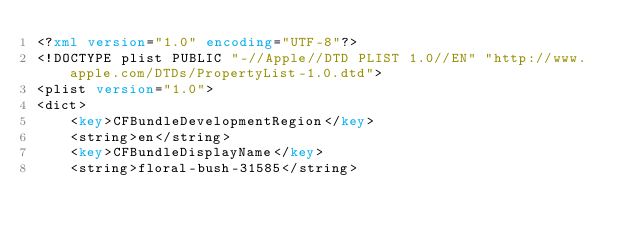<code> <loc_0><loc_0><loc_500><loc_500><_XML_><?xml version="1.0" encoding="UTF-8"?>
<!DOCTYPE plist PUBLIC "-//Apple//DTD PLIST 1.0//EN" "http://www.apple.com/DTDs/PropertyList-1.0.dtd">
<plist version="1.0">
<dict>
	<key>CFBundleDevelopmentRegion</key>
	<string>en</string>
	<key>CFBundleDisplayName</key>
	<string>floral-bush-31585</string></code> 